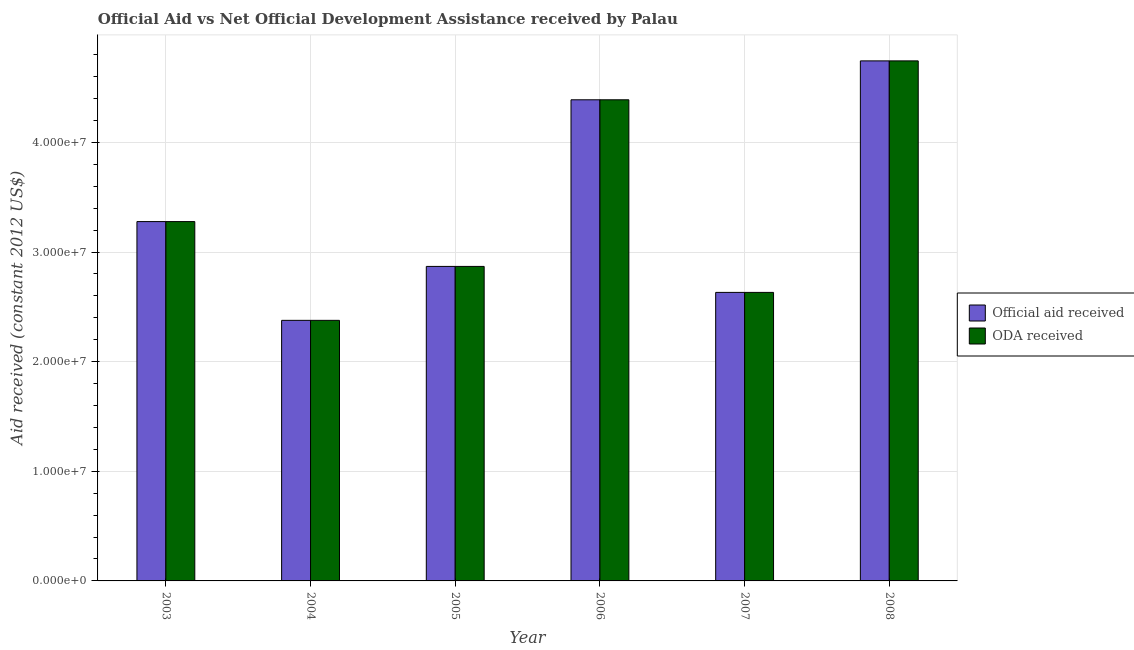How many different coloured bars are there?
Your answer should be compact. 2. How many groups of bars are there?
Give a very brief answer. 6. Are the number of bars per tick equal to the number of legend labels?
Offer a very short reply. Yes. Are the number of bars on each tick of the X-axis equal?
Offer a terse response. Yes. In how many cases, is the number of bars for a given year not equal to the number of legend labels?
Offer a terse response. 0. What is the oda received in 2007?
Ensure brevity in your answer.  2.63e+07. Across all years, what is the maximum oda received?
Ensure brevity in your answer.  4.74e+07. Across all years, what is the minimum official aid received?
Provide a succinct answer. 2.38e+07. In which year was the oda received minimum?
Provide a short and direct response. 2004. What is the total oda received in the graph?
Your answer should be compact. 2.03e+08. What is the difference between the oda received in 2005 and that in 2007?
Your answer should be compact. 2.37e+06. What is the difference between the oda received in 2004 and the official aid received in 2007?
Your response must be concise. -2.55e+06. What is the average official aid received per year?
Make the answer very short. 3.38e+07. In how many years, is the official aid received greater than 40000000 US$?
Offer a very short reply. 2. What is the ratio of the oda received in 2003 to that in 2004?
Make the answer very short. 1.38. Is the oda received in 2006 less than that in 2008?
Ensure brevity in your answer.  Yes. What is the difference between the highest and the second highest official aid received?
Your response must be concise. 3.55e+06. What is the difference between the highest and the lowest official aid received?
Give a very brief answer. 2.37e+07. What does the 2nd bar from the left in 2004 represents?
Make the answer very short. ODA received. What does the 1st bar from the right in 2006 represents?
Make the answer very short. ODA received. Are all the bars in the graph horizontal?
Your response must be concise. No. How many years are there in the graph?
Provide a short and direct response. 6. What is the difference between two consecutive major ticks on the Y-axis?
Keep it short and to the point. 1.00e+07. Where does the legend appear in the graph?
Provide a short and direct response. Center right. How are the legend labels stacked?
Your response must be concise. Vertical. What is the title of the graph?
Provide a succinct answer. Official Aid vs Net Official Development Assistance received by Palau . Does "Primary income" appear as one of the legend labels in the graph?
Keep it short and to the point. No. What is the label or title of the Y-axis?
Keep it short and to the point. Aid received (constant 2012 US$). What is the Aid received (constant 2012 US$) in Official aid received in 2003?
Give a very brief answer. 3.28e+07. What is the Aid received (constant 2012 US$) of ODA received in 2003?
Keep it short and to the point. 3.28e+07. What is the Aid received (constant 2012 US$) in Official aid received in 2004?
Offer a very short reply. 2.38e+07. What is the Aid received (constant 2012 US$) in ODA received in 2004?
Ensure brevity in your answer.  2.38e+07. What is the Aid received (constant 2012 US$) in Official aid received in 2005?
Make the answer very short. 2.87e+07. What is the Aid received (constant 2012 US$) in ODA received in 2005?
Offer a terse response. 2.87e+07. What is the Aid received (constant 2012 US$) of Official aid received in 2006?
Your answer should be compact. 4.39e+07. What is the Aid received (constant 2012 US$) in ODA received in 2006?
Your answer should be compact. 4.39e+07. What is the Aid received (constant 2012 US$) in Official aid received in 2007?
Give a very brief answer. 2.63e+07. What is the Aid received (constant 2012 US$) of ODA received in 2007?
Offer a terse response. 2.63e+07. What is the Aid received (constant 2012 US$) in Official aid received in 2008?
Offer a terse response. 4.74e+07. What is the Aid received (constant 2012 US$) of ODA received in 2008?
Offer a terse response. 4.74e+07. Across all years, what is the maximum Aid received (constant 2012 US$) of Official aid received?
Your answer should be compact. 4.74e+07. Across all years, what is the maximum Aid received (constant 2012 US$) of ODA received?
Give a very brief answer. 4.74e+07. Across all years, what is the minimum Aid received (constant 2012 US$) of Official aid received?
Your response must be concise. 2.38e+07. Across all years, what is the minimum Aid received (constant 2012 US$) of ODA received?
Keep it short and to the point. 2.38e+07. What is the total Aid received (constant 2012 US$) in Official aid received in the graph?
Offer a very short reply. 2.03e+08. What is the total Aid received (constant 2012 US$) in ODA received in the graph?
Ensure brevity in your answer.  2.03e+08. What is the difference between the Aid received (constant 2012 US$) in Official aid received in 2003 and that in 2004?
Keep it short and to the point. 9.01e+06. What is the difference between the Aid received (constant 2012 US$) of ODA received in 2003 and that in 2004?
Offer a very short reply. 9.01e+06. What is the difference between the Aid received (constant 2012 US$) of Official aid received in 2003 and that in 2005?
Offer a very short reply. 4.09e+06. What is the difference between the Aid received (constant 2012 US$) of ODA received in 2003 and that in 2005?
Give a very brief answer. 4.09e+06. What is the difference between the Aid received (constant 2012 US$) of Official aid received in 2003 and that in 2006?
Ensure brevity in your answer.  -1.11e+07. What is the difference between the Aid received (constant 2012 US$) of ODA received in 2003 and that in 2006?
Give a very brief answer. -1.11e+07. What is the difference between the Aid received (constant 2012 US$) of Official aid received in 2003 and that in 2007?
Keep it short and to the point. 6.46e+06. What is the difference between the Aid received (constant 2012 US$) of ODA received in 2003 and that in 2007?
Provide a short and direct response. 6.46e+06. What is the difference between the Aid received (constant 2012 US$) of Official aid received in 2003 and that in 2008?
Provide a short and direct response. -1.47e+07. What is the difference between the Aid received (constant 2012 US$) of ODA received in 2003 and that in 2008?
Your response must be concise. -1.47e+07. What is the difference between the Aid received (constant 2012 US$) in Official aid received in 2004 and that in 2005?
Your answer should be very brief. -4.92e+06. What is the difference between the Aid received (constant 2012 US$) of ODA received in 2004 and that in 2005?
Ensure brevity in your answer.  -4.92e+06. What is the difference between the Aid received (constant 2012 US$) in Official aid received in 2004 and that in 2006?
Give a very brief answer. -2.01e+07. What is the difference between the Aid received (constant 2012 US$) of ODA received in 2004 and that in 2006?
Provide a succinct answer. -2.01e+07. What is the difference between the Aid received (constant 2012 US$) in Official aid received in 2004 and that in 2007?
Your answer should be compact. -2.55e+06. What is the difference between the Aid received (constant 2012 US$) of ODA received in 2004 and that in 2007?
Give a very brief answer. -2.55e+06. What is the difference between the Aid received (constant 2012 US$) of Official aid received in 2004 and that in 2008?
Provide a succinct answer. -2.37e+07. What is the difference between the Aid received (constant 2012 US$) of ODA received in 2004 and that in 2008?
Provide a short and direct response. -2.37e+07. What is the difference between the Aid received (constant 2012 US$) of Official aid received in 2005 and that in 2006?
Keep it short and to the point. -1.52e+07. What is the difference between the Aid received (constant 2012 US$) in ODA received in 2005 and that in 2006?
Provide a short and direct response. -1.52e+07. What is the difference between the Aid received (constant 2012 US$) in Official aid received in 2005 and that in 2007?
Your response must be concise. 2.37e+06. What is the difference between the Aid received (constant 2012 US$) in ODA received in 2005 and that in 2007?
Ensure brevity in your answer.  2.37e+06. What is the difference between the Aid received (constant 2012 US$) in Official aid received in 2005 and that in 2008?
Your answer should be compact. -1.88e+07. What is the difference between the Aid received (constant 2012 US$) of ODA received in 2005 and that in 2008?
Ensure brevity in your answer.  -1.88e+07. What is the difference between the Aid received (constant 2012 US$) in Official aid received in 2006 and that in 2007?
Provide a short and direct response. 1.76e+07. What is the difference between the Aid received (constant 2012 US$) of ODA received in 2006 and that in 2007?
Make the answer very short. 1.76e+07. What is the difference between the Aid received (constant 2012 US$) in Official aid received in 2006 and that in 2008?
Provide a short and direct response. -3.55e+06. What is the difference between the Aid received (constant 2012 US$) in ODA received in 2006 and that in 2008?
Make the answer very short. -3.55e+06. What is the difference between the Aid received (constant 2012 US$) in Official aid received in 2007 and that in 2008?
Your response must be concise. -2.11e+07. What is the difference between the Aid received (constant 2012 US$) of ODA received in 2007 and that in 2008?
Offer a terse response. -2.11e+07. What is the difference between the Aid received (constant 2012 US$) of Official aid received in 2003 and the Aid received (constant 2012 US$) of ODA received in 2004?
Provide a short and direct response. 9.01e+06. What is the difference between the Aid received (constant 2012 US$) of Official aid received in 2003 and the Aid received (constant 2012 US$) of ODA received in 2005?
Make the answer very short. 4.09e+06. What is the difference between the Aid received (constant 2012 US$) of Official aid received in 2003 and the Aid received (constant 2012 US$) of ODA received in 2006?
Your answer should be compact. -1.11e+07. What is the difference between the Aid received (constant 2012 US$) in Official aid received in 2003 and the Aid received (constant 2012 US$) in ODA received in 2007?
Make the answer very short. 6.46e+06. What is the difference between the Aid received (constant 2012 US$) in Official aid received in 2003 and the Aid received (constant 2012 US$) in ODA received in 2008?
Provide a succinct answer. -1.47e+07. What is the difference between the Aid received (constant 2012 US$) of Official aid received in 2004 and the Aid received (constant 2012 US$) of ODA received in 2005?
Your response must be concise. -4.92e+06. What is the difference between the Aid received (constant 2012 US$) in Official aid received in 2004 and the Aid received (constant 2012 US$) in ODA received in 2006?
Your answer should be compact. -2.01e+07. What is the difference between the Aid received (constant 2012 US$) in Official aid received in 2004 and the Aid received (constant 2012 US$) in ODA received in 2007?
Offer a terse response. -2.55e+06. What is the difference between the Aid received (constant 2012 US$) of Official aid received in 2004 and the Aid received (constant 2012 US$) of ODA received in 2008?
Your answer should be compact. -2.37e+07. What is the difference between the Aid received (constant 2012 US$) in Official aid received in 2005 and the Aid received (constant 2012 US$) in ODA received in 2006?
Provide a short and direct response. -1.52e+07. What is the difference between the Aid received (constant 2012 US$) of Official aid received in 2005 and the Aid received (constant 2012 US$) of ODA received in 2007?
Provide a short and direct response. 2.37e+06. What is the difference between the Aid received (constant 2012 US$) in Official aid received in 2005 and the Aid received (constant 2012 US$) in ODA received in 2008?
Ensure brevity in your answer.  -1.88e+07. What is the difference between the Aid received (constant 2012 US$) in Official aid received in 2006 and the Aid received (constant 2012 US$) in ODA received in 2007?
Your response must be concise. 1.76e+07. What is the difference between the Aid received (constant 2012 US$) in Official aid received in 2006 and the Aid received (constant 2012 US$) in ODA received in 2008?
Offer a very short reply. -3.55e+06. What is the difference between the Aid received (constant 2012 US$) in Official aid received in 2007 and the Aid received (constant 2012 US$) in ODA received in 2008?
Your response must be concise. -2.11e+07. What is the average Aid received (constant 2012 US$) in Official aid received per year?
Your answer should be very brief. 3.38e+07. What is the average Aid received (constant 2012 US$) of ODA received per year?
Your answer should be compact. 3.38e+07. In the year 2004, what is the difference between the Aid received (constant 2012 US$) of Official aid received and Aid received (constant 2012 US$) of ODA received?
Make the answer very short. 0. In the year 2005, what is the difference between the Aid received (constant 2012 US$) of Official aid received and Aid received (constant 2012 US$) of ODA received?
Keep it short and to the point. 0. In the year 2006, what is the difference between the Aid received (constant 2012 US$) in Official aid received and Aid received (constant 2012 US$) in ODA received?
Your response must be concise. 0. In the year 2007, what is the difference between the Aid received (constant 2012 US$) in Official aid received and Aid received (constant 2012 US$) in ODA received?
Ensure brevity in your answer.  0. In the year 2008, what is the difference between the Aid received (constant 2012 US$) of Official aid received and Aid received (constant 2012 US$) of ODA received?
Provide a short and direct response. 0. What is the ratio of the Aid received (constant 2012 US$) of Official aid received in 2003 to that in 2004?
Your answer should be compact. 1.38. What is the ratio of the Aid received (constant 2012 US$) of ODA received in 2003 to that in 2004?
Your response must be concise. 1.38. What is the ratio of the Aid received (constant 2012 US$) of Official aid received in 2003 to that in 2005?
Keep it short and to the point. 1.14. What is the ratio of the Aid received (constant 2012 US$) of ODA received in 2003 to that in 2005?
Provide a succinct answer. 1.14. What is the ratio of the Aid received (constant 2012 US$) of Official aid received in 2003 to that in 2006?
Your answer should be very brief. 0.75. What is the ratio of the Aid received (constant 2012 US$) of ODA received in 2003 to that in 2006?
Keep it short and to the point. 0.75. What is the ratio of the Aid received (constant 2012 US$) of Official aid received in 2003 to that in 2007?
Offer a terse response. 1.25. What is the ratio of the Aid received (constant 2012 US$) in ODA received in 2003 to that in 2007?
Ensure brevity in your answer.  1.25. What is the ratio of the Aid received (constant 2012 US$) in Official aid received in 2003 to that in 2008?
Provide a succinct answer. 0.69. What is the ratio of the Aid received (constant 2012 US$) of ODA received in 2003 to that in 2008?
Ensure brevity in your answer.  0.69. What is the ratio of the Aid received (constant 2012 US$) in Official aid received in 2004 to that in 2005?
Your answer should be very brief. 0.83. What is the ratio of the Aid received (constant 2012 US$) in ODA received in 2004 to that in 2005?
Your answer should be very brief. 0.83. What is the ratio of the Aid received (constant 2012 US$) of Official aid received in 2004 to that in 2006?
Give a very brief answer. 0.54. What is the ratio of the Aid received (constant 2012 US$) of ODA received in 2004 to that in 2006?
Your answer should be very brief. 0.54. What is the ratio of the Aid received (constant 2012 US$) of Official aid received in 2004 to that in 2007?
Your answer should be very brief. 0.9. What is the ratio of the Aid received (constant 2012 US$) of ODA received in 2004 to that in 2007?
Your response must be concise. 0.9. What is the ratio of the Aid received (constant 2012 US$) of Official aid received in 2004 to that in 2008?
Make the answer very short. 0.5. What is the ratio of the Aid received (constant 2012 US$) in ODA received in 2004 to that in 2008?
Make the answer very short. 0.5. What is the ratio of the Aid received (constant 2012 US$) in Official aid received in 2005 to that in 2006?
Make the answer very short. 0.65. What is the ratio of the Aid received (constant 2012 US$) of ODA received in 2005 to that in 2006?
Make the answer very short. 0.65. What is the ratio of the Aid received (constant 2012 US$) of Official aid received in 2005 to that in 2007?
Provide a succinct answer. 1.09. What is the ratio of the Aid received (constant 2012 US$) in ODA received in 2005 to that in 2007?
Your response must be concise. 1.09. What is the ratio of the Aid received (constant 2012 US$) in Official aid received in 2005 to that in 2008?
Ensure brevity in your answer.  0.6. What is the ratio of the Aid received (constant 2012 US$) of ODA received in 2005 to that in 2008?
Provide a short and direct response. 0.6. What is the ratio of the Aid received (constant 2012 US$) of Official aid received in 2006 to that in 2007?
Make the answer very short. 1.67. What is the ratio of the Aid received (constant 2012 US$) in ODA received in 2006 to that in 2007?
Provide a succinct answer. 1.67. What is the ratio of the Aid received (constant 2012 US$) in Official aid received in 2006 to that in 2008?
Your response must be concise. 0.93. What is the ratio of the Aid received (constant 2012 US$) of ODA received in 2006 to that in 2008?
Keep it short and to the point. 0.93. What is the ratio of the Aid received (constant 2012 US$) of Official aid received in 2007 to that in 2008?
Keep it short and to the point. 0.55. What is the ratio of the Aid received (constant 2012 US$) in ODA received in 2007 to that in 2008?
Provide a succinct answer. 0.55. What is the difference between the highest and the second highest Aid received (constant 2012 US$) in Official aid received?
Ensure brevity in your answer.  3.55e+06. What is the difference between the highest and the second highest Aid received (constant 2012 US$) in ODA received?
Ensure brevity in your answer.  3.55e+06. What is the difference between the highest and the lowest Aid received (constant 2012 US$) in Official aid received?
Offer a terse response. 2.37e+07. What is the difference between the highest and the lowest Aid received (constant 2012 US$) in ODA received?
Ensure brevity in your answer.  2.37e+07. 